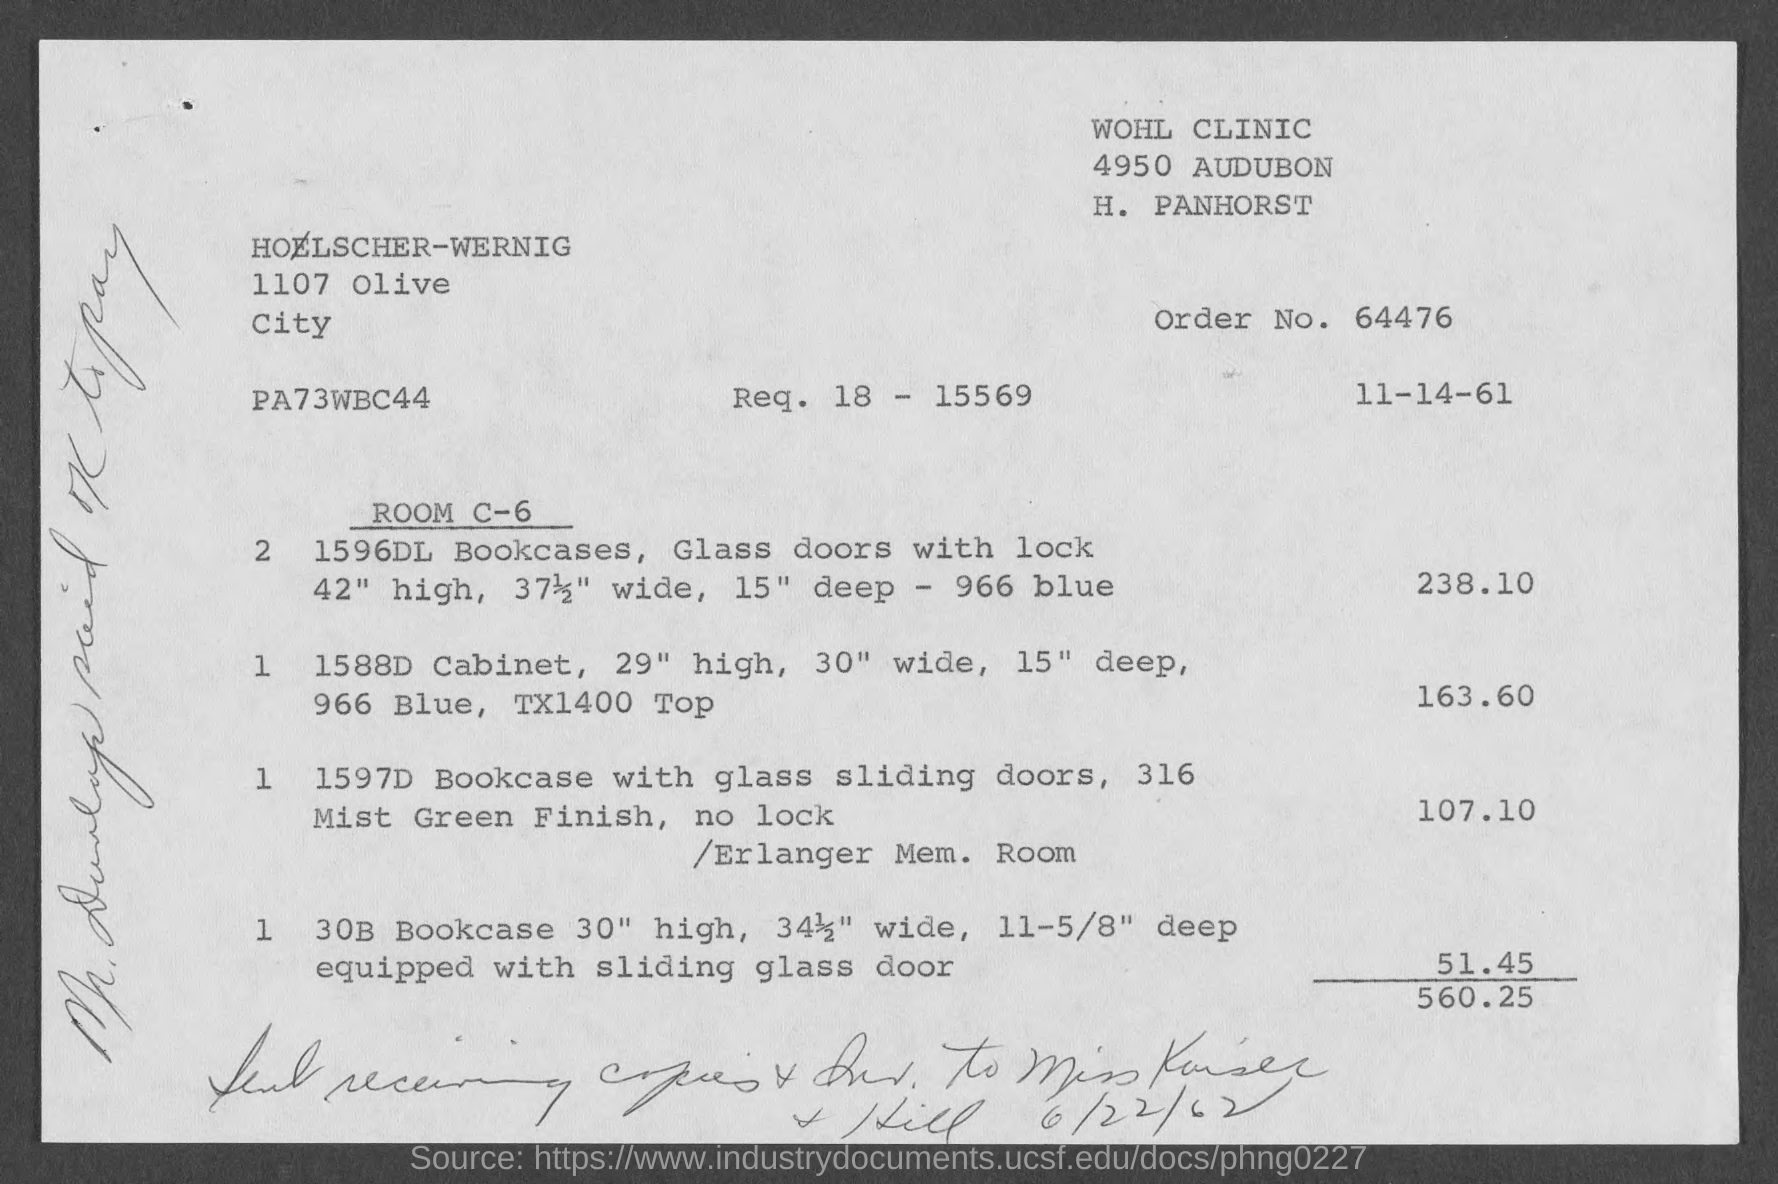What is the order no.?
Keep it short and to the point. 64476. What is the name of the clinic in the top part of the document?
Your answer should be compact. Wohl clinic. What is the date printed on the top right side of the document?
Offer a terse response. 11-14-61. What is the room number?
Make the answer very short. Room c-6. What is the value of the two "1596dl bookcases"?
Provide a succinct answer. 238.10. What is the value of the "1597d bookcase"?
Ensure brevity in your answer.  107.10. What is the value of the "30b bookcase"?
Provide a short and direct response. 51.45. What is the value of the "1588d cabinet"?
Your response must be concise. 163.60. What is the date written on the bottom of the document?
Make the answer very short. 6/22/62. What is the height of the "1596dl bookcase"?
Give a very brief answer. 42" high. 